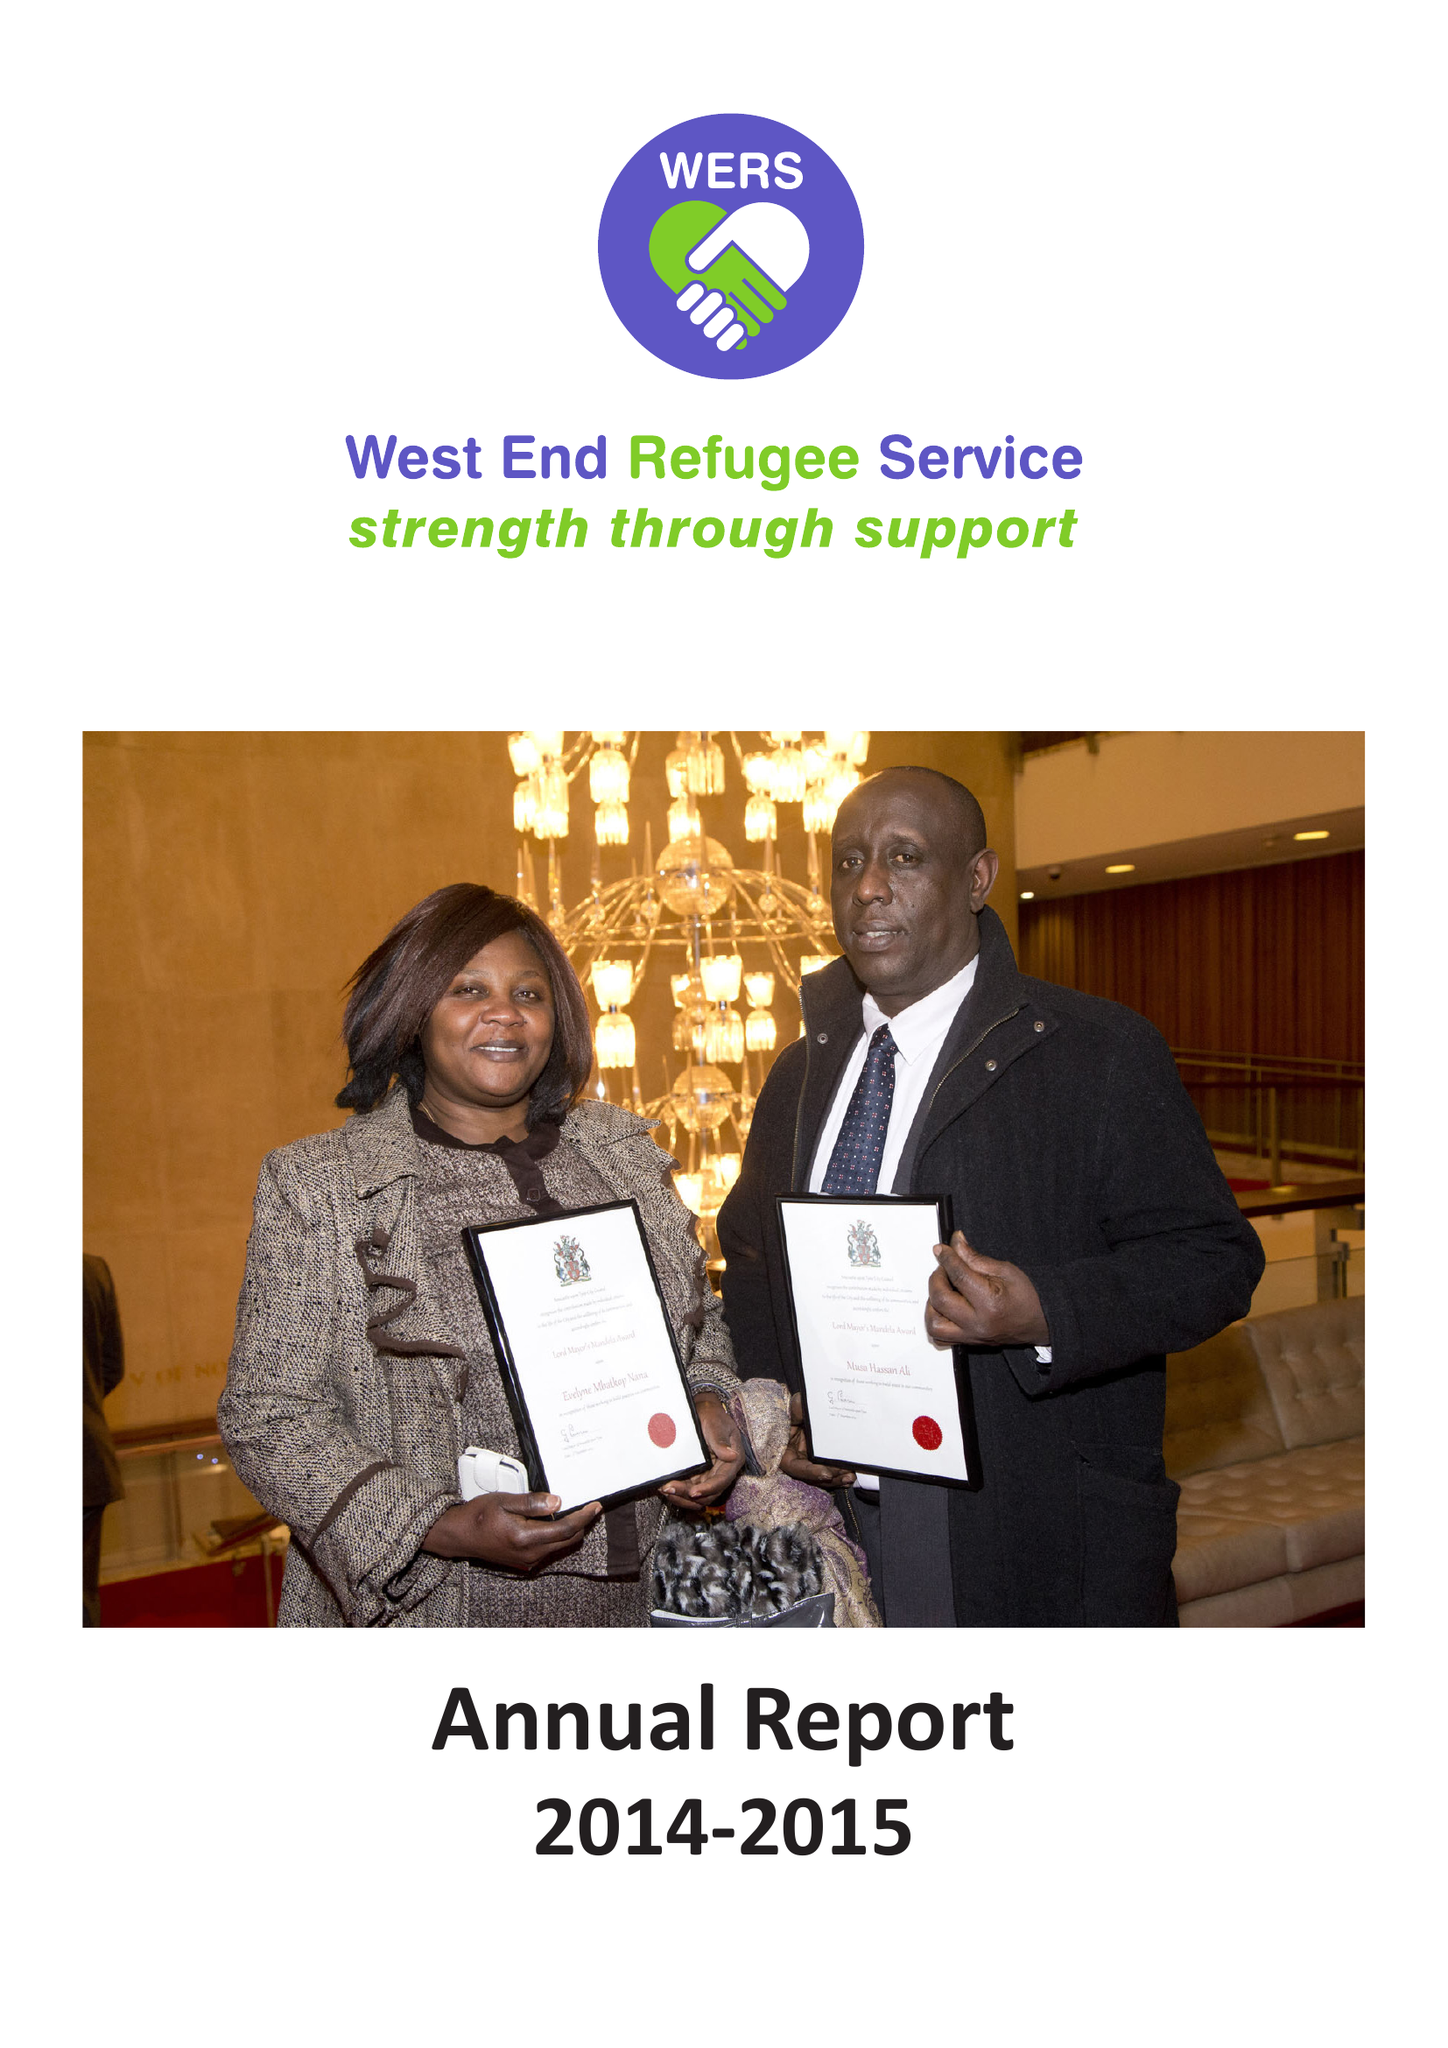What is the value for the address__post_town?
Answer the question using a single word or phrase. NEWCASTLE UPON TYNE 